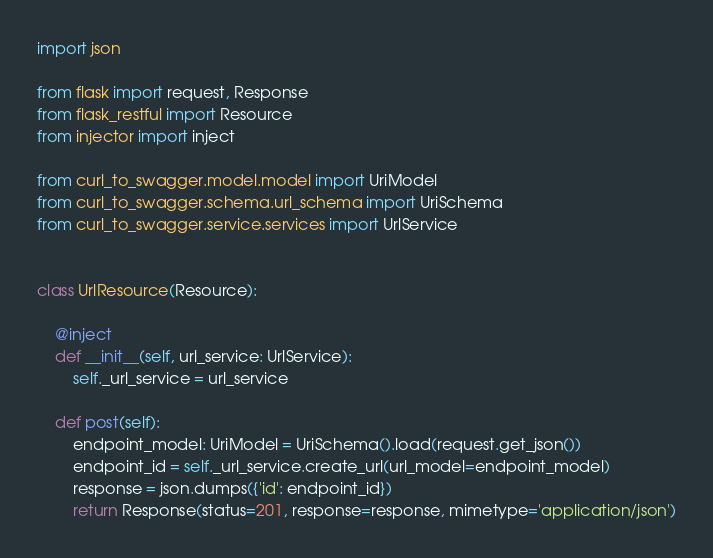<code> <loc_0><loc_0><loc_500><loc_500><_Python_>import json

from flask import request, Response
from flask_restful import Resource
from injector import inject

from curl_to_swagger.model.model import UriModel
from curl_to_swagger.schema.url_schema import UriSchema
from curl_to_swagger.service.services import UrlService


class UrlResource(Resource):

    @inject
    def __init__(self, url_service: UrlService):
        self._url_service = url_service

    def post(self):
        endpoint_model: UriModel = UriSchema().load(request.get_json())
        endpoint_id = self._url_service.create_url(url_model=endpoint_model)
        response = json.dumps({'id': endpoint_id})
        return Response(status=201, response=response, mimetype='application/json')
</code> 